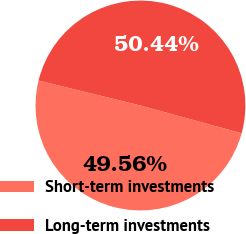Convert chart. <chart><loc_0><loc_0><loc_500><loc_500><pie_chart><fcel>Short-term investments<fcel>Long-term investments<nl><fcel>49.56%<fcel>50.44%<nl></chart> 